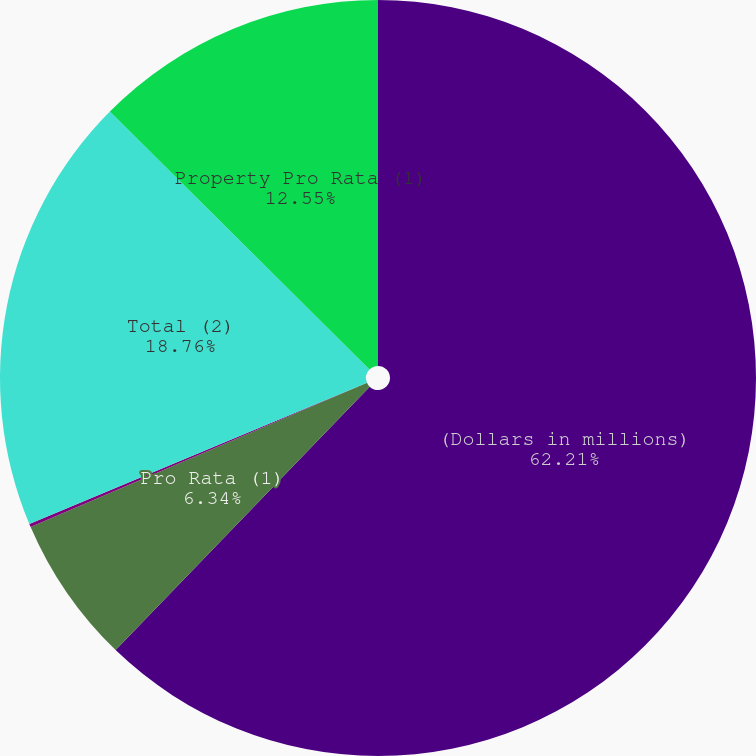<chart> <loc_0><loc_0><loc_500><loc_500><pie_chart><fcel>(Dollars in millions)<fcel>Pro Rata (1)<fcel>Excess<fcel>Total (2)<fcel>Property Pro Rata (1)<nl><fcel>62.21%<fcel>6.34%<fcel>0.14%<fcel>18.76%<fcel>12.55%<nl></chart> 